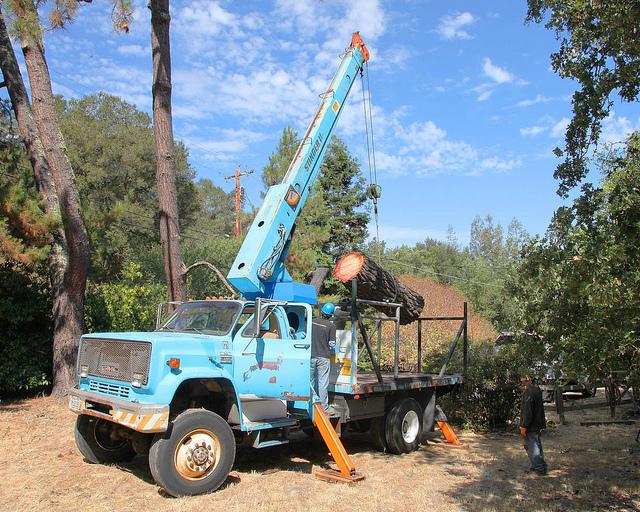What is being removed in this image?
Write a very short answer. Tree. Is this in a city area?
Write a very short answer. No. What color is the truck?
Keep it brief. Blue. 